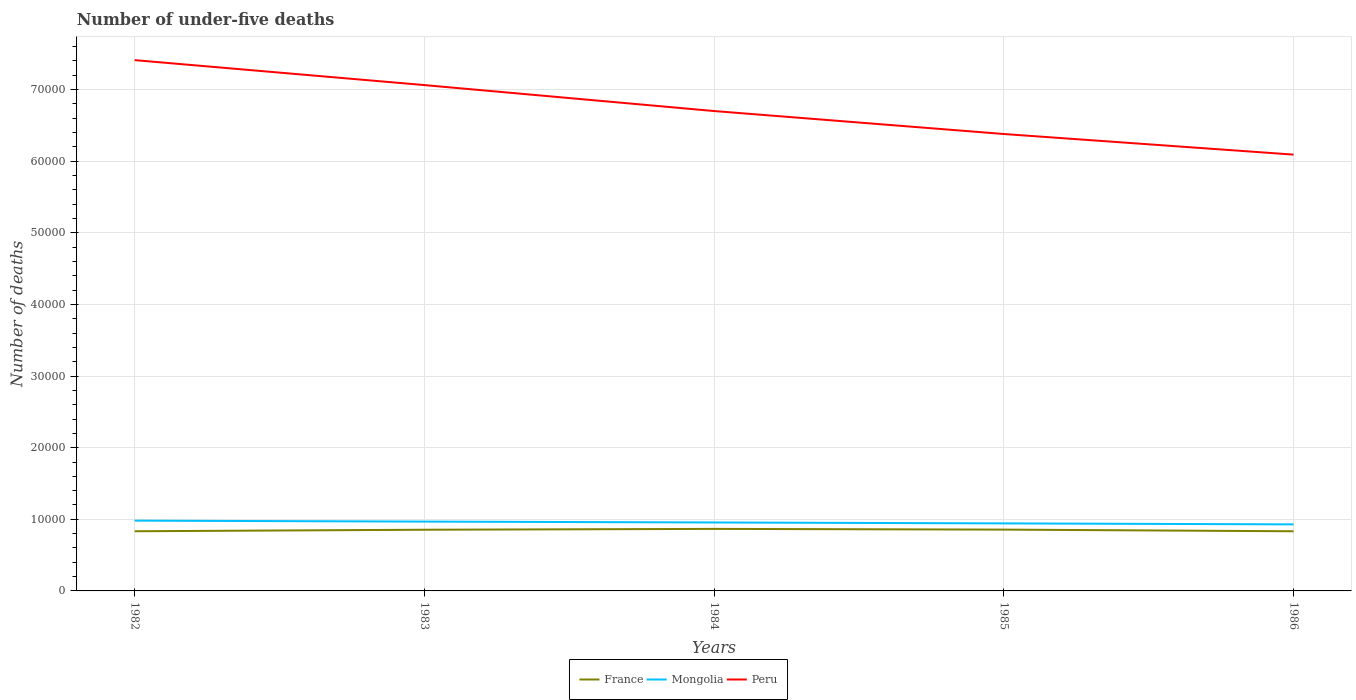How many different coloured lines are there?
Offer a very short reply. 3. Is the number of lines equal to the number of legend labels?
Ensure brevity in your answer.  Yes. Across all years, what is the maximum number of under-five deaths in France?
Your response must be concise. 8329. What is the total number of under-five deaths in Peru in the graph?
Offer a terse response. 1.03e+04. What is the difference between the highest and the second highest number of under-five deaths in Mongolia?
Ensure brevity in your answer.  523. Is the number of under-five deaths in Mongolia strictly greater than the number of under-five deaths in Peru over the years?
Keep it short and to the point. Yes. How many years are there in the graph?
Provide a succinct answer. 5. What is the difference between two consecutive major ticks on the Y-axis?
Your answer should be very brief. 10000. Does the graph contain grids?
Provide a short and direct response. Yes. How many legend labels are there?
Ensure brevity in your answer.  3. How are the legend labels stacked?
Keep it short and to the point. Horizontal. What is the title of the graph?
Provide a succinct answer. Number of under-five deaths. What is the label or title of the Y-axis?
Make the answer very short. Number of deaths. What is the Number of deaths in France in 1982?
Your response must be concise. 8331. What is the Number of deaths of Mongolia in 1982?
Ensure brevity in your answer.  9814. What is the Number of deaths in Peru in 1982?
Offer a very short reply. 7.41e+04. What is the Number of deaths in France in 1983?
Make the answer very short. 8544. What is the Number of deaths of Mongolia in 1983?
Keep it short and to the point. 9680. What is the Number of deaths in Peru in 1983?
Keep it short and to the point. 7.06e+04. What is the Number of deaths of France in 1984?
Your answer should be compact. 8662. What is the Number of deaths in Mongolia in 1984?
Ensure brevity in your answer.  9558. What is the Number of deaths in Peru in 1984?
Provide a succinct answer. 6.70e+04. What is the Number of deaths in France in 1985?
Keep it short and to the point. 8561. What is the Number of deaths in Mongolia in 1985?
Offer a terse response. 9430. What is the Number of deaths in Peru in 1985?
Ensure brevity in your answer.  6.38e+04. What is the Number of deaths of France in 1986?
Offer a very short reply. 8329. What is the Number of deaths in Mongolia in 1986?
Offer a terse response. 9291. What is the Number of deaths of Peru in 1986?
Offer a very short reply. 6.09e+04. Across all years, what is the maximum Number of deaths in France?
Make the answer very short. 8662. Across all years, what is the maximum Number of deaths in Mongolia?
Offer a terse response. 9814. Across all years, what is the maximum Number of deaths of Peru?
Ensure brevity in your answer.  7.41e+04. Across all years, what is the minimum Number of deaths in France?
Offer a very short reply. 8329. Across all years, what is the minimum Number of deaths of Mongolia?
Your response must be concise. 9291. Across all years, what is the minimum Number of deaths of Peru?
Provide a short and direct response. 6.09e+04. What is the total Number of deaths in France in the graph?
Keep it short and to the point. 4.24e+04. What is the total Number of deaths in Mongolia in the graph?
Your answer should be very brief. 4.78e+04. What is the total Number of deaths in Peru in the graph?
Provide a succinct answer. 3.36e+05. What is the difference between the Number of deaths of France in 1982 and that in 1983?
Your answer should be very brief. -213. What is the difference between the Number of deaths of Mongolia in 1982 and that in 1983?
Your response must be concise. 134. What is the difference between the Number of deaths of Peru in 1982 and that in 1983?
Make the answer very short. 3484. What is the difference between the Number of deaths in France in 1982 and that in 1984?
Your answer should be compact. -331. What is the difference between the Number of deaths in Mongolia in 1982 and that in 1984?
Your answer should be very brief. 256. What is the difference between the Number of deaths of Peru in 1982 and that in 1984?
Your response must be concise. 7108. What is the difference between the Number of deaths of France in 1982 and that in 1985?
Ensure brevity in your answer.  -230. What is the difference between the Number of deaths in Mongolia in 1982 and that in 1985?
Your answer should be compact. 384. What is the difference between the Number of deaths of Peru in 1982 and that in 1985?
Offer a very short reply. 1.03e+04. What is the difference between the Number of deaths in France in 1982 and that in 1986?
Your answer should be very brief. 2. What is the difference between the Number of deaths in Mongolia in 1982 and that in 1986?
Your response must be concise. 523. What is the difference between the Number of deaths of Peru in 1982 and that in 1986?
Your response must be concise. 1.32e+04. What is the difference between the Number of deaths of France in 1983 and that in 1984?
Give a very brief answer. -118. What is the difference between the Number of deaths in Mongolia in 1983 and that in 1984?
Your answer should be compact. 122. What is the difference between the Number of deaths in Peru in 1983 and that in 1984?
Offer a very short reply. 3624. What is the difference between the Number of deaths in Mongolia in 1983 and that in 1985?
Make the answer very short. 250. What is the difference between the Number of deaths of Peru in 1983 and that in 1985?
Keep it short and to the point. 6831. What is the difference between the Number of deaths of France in 1983 and that in 1986?
Ensure brevity in your answer.  215. What is the difference between the Number of deaths of Mongolia in 1983 and that in 1986?
Your answer should be compact. 389. What is the difference between the Number of deaths in Peru in 1983 and that in 1986?
Give a very brief answer. 9709. What is the difference between the Number of deaths in France in 1984 and that in 1985?
Offer a very short reply. 101. What is the difference between the Number of deaths in Mongolia in 1984 and that in 1985?
Provide a succinct answer. 128. What is the difference between the Number of deaths in Peru in 1984 and that in 1985?
Your answer should be compact. 3207. What is the difference between the Number of deaths of France in 1984 and that in 1986?
Ensure brevity in your answer.  333. What is the difference between the Number of deaths of Mongolia in 1984 and that in 1986?
Keep it short and to the point. 267. What is the difference between the Number of deaths of Peru in 1984 and that in 1986?
Keep it short and to the point. 6085. What is the difference between the Number of deaths in France in 1985 and that in 1986?
Keep it short and to the point. 232. What is the difference between the Number of deaths in Mongolia in 1985 and that in 1986?
Your response must be concise. 139. What is the difference between the Number of deaths in Peru in 1985 and that in 1986?
Provide a short and direct response. 2878. What is the difference between the Number of deaths in France in 1982 and the Number of deaths in Mongolia in 1983?
Provide a short and direct response. -1349. What is the difference between the Number of deaths of France in 1982 and the Number of deaths of Peru in 1983?
Ensure brevity in your answer.  -6.23e+04. What is the difference between the Number of deaths of Mongolia in 1982 and the Number of deaths of Peru in 1983?
Your answer should be compact. -6.08e+04. What is the difference between the Number of deaths in France in 1982 and the Number of deaths in Mongolia in 1984?
Keep it short and to the point. -1227. What is the difference between the Number of deaths in France in 1982 and the Number of deaths in Peru in 1984?
Ensure brevity in your answer.  -5.87e+04. What is the difference between the Number of deaths of Mongolia in 1982 and the Number of deaths of Peru in 1984?
Your answer should be very brief. -5.72e+04. What is the difference between the Number of deaths of France in 1982 and the Number of deaths of Mongolia in 1985?
Ensure brevity in your answer.  -1099. What is the difference between the Number of deaths in France in 1982 and the Number of deaths in Peru in 1985?
Give a very brief answer. -5.55e+04. What is the difference between the Number of deaths of Mongolia in 1982 and the Number of deaths of Peru in 1985?
Offer a very short reply. -5.40e+04. What is the difference between the Number of deaths of France in 1982 and the Number of deaths of Mongolia in 1986?
Your answer should be very brief. -960. What is the difference between the Number of deaths of France in 1982 and the Number of deaths of Peru in 1986?
Provide a succinct answer. -5.26e+04. What is the difference between the Number of deaths of Mongolia in 1982 and the Number of deaths of Peru in 1986?
Make the answer very short. -5.11e+04. What is the difference between the Number of deaths of France in 1983 and the Number of deaths of Mongolia in 1984?
Your response must be concise. -1014. What is the difference between the Number of deaths of France in 1983 and the Number of deaths of Peru in 1984?
Provide a succinct answer. -5.85e+04. What is the difference between the Number of deaths of Mongolia in 1983 and the Number of deaths of Peru in 1984?
Ensure brevity in your answer.  -5.73e+04. What is the difference between the Number of deaths in France in 1983 and the Number of deaths in Mongolia in 1985?
Offer a terse response. -886. What is the difference between the Number of deaths of France in 1983 and the Number of deaths of Peru in 1985?
Offer a very short reply. -5.53e+04. What is the difference between the Number of deaths in Mongolia in 1983 and the Number of deaths in Peru in 1985?
Provide a short and direct response. -5.41e+04. What is the difference between the Number of deaths of France in 1983 and the Number of deaths of Mongolia in 1986?
Provide a succinct answer. -747. What is the difference between the Number of deaths in France in 1983 and the Number of deaths in Peru in 1986?
Offer a very short reply. -5.24e+04. What is the difference between the Number of deaths in Mongolia in 1983 and the Number of deaths in Peru in 1986?
Offer a terse response. -5.12e+04. What is the difference between the Number of deaths in France in 1984 and the Number of deaths in Mongolia in 1985?
Offer a very short reply. -768. What is the difference between the Number of deaths of France in 1984 and the Number of deaths of Peru in 1985?
Your answer should be compact. -5.51e+04. What is the difference between the Number of deaths in Mongolia in 1984 and the Number of deaths in Peru in 1985?
Keep it short and to the point. -5.42e+04. What is the difference between the Number of deaths in France in 1984 and the Number of deaths in Mongolia in 1986?
Your answer should be very brief. -629. What is the difference between the Number of deaths of France in 1984 and the Number of deaths of Peru in 1986?
Provide a succinct answer. -5.23e+04. What is the difference between the Number of deaths of Mongolia in 1984 and the Number of deaths of Peru in 1986?
Offer a very short reply. -5.14e+04. What is the difference between the Number of deaths in France in 1985 and the Number of deaths in Mongolia in 1986?
Offer a very short reply. -730. What is the difference between the Number of deaths in France in 1985 and the Number of deaths in Peru in 1986?
Provide a short and direct response. -5.24e+04. What is the difference between the Number of deaths of Mongolia in 1985 and the Number of deaths of Peru in 1986?
Offer a terse response. -5.15e+04. What is the average Number of deaths in France per year?
Make the answer very short. 8485.4. What is the average Number of deaths in Mongolia per year?
Offer a very short reply. 9554.6. What is the average Number of deaths of Peru per year?
Ensure brevity in your answer.  6.73e+04. In the year 1982, what is the difference between the Number of deaths in France and Number of deaths in Mongolia?
Your response must be concise. -1483. In the year 1982, what is the difference between the Number of deaths in France and Number of deaths in Peru?
Offer a very short reply. -6.58e+04. In the year 1982, what is the difference between the Number of deaths of Mongolia and Number of deaths of Peru?
Provide a short and direct response. -6.43e+04. In the year 1983, what is the difference between the Number of deaths in France and Number of deaths in Mongolia?
Your response must be concise. -1136. In the year 1983, what is the difference between the Number of deaths of France and Number of deaths of Peru?
Your response must be concise. -6.21e+04. In the year 1983, what is the difference between the Number of deaths of Mongolia and Number of deaths of Peru?
Your answer should be compact. -6.09e+04. In the year 1984, what is the difference between the Number of deaths in France and Number of deaths in Mongolia?
Your answer should be compact. -896. In the year 1984, what is the difference between the Number of deaths of France and Number of deaths of Peru?
Offer a very short reply. -5.83e+04. In the year 1984, what is the difference between the Number of deaths of Mongolia and Number of deaths of Peru?
Offer a very short reply. -5.74e+04. In the year 1985, what is the difference between the Number of deaths of France and Number of deaths of Mongolia?
Your answer should be compact. -869. In the year 1985, what is the difference between the Number of deaths of France and Number of deaths of Peru?
Provide a succinct answer. -5.52e+04. In the year 1985, what is the difference between the Number of deaths in Mongolia and Number of deaths in Peru?
Provide a short and direct response. -5.44e+04. In the year 1986, what is the difference between the Number of deaths of France and Number of deaths of Mongolia?
Your answer should be very brief. -962. In the year 1986, what is the difference between the Number of deaths of France and Number of deaths of Peru?
Give a very brief answer. -5.26e+04. In the year 1986, what is the difference between the Number of deaths of Mongolia and Number of deaths of Peru?
Offer a very short reply. -5.16e+04. What is the ratio of the Number of deaths of France in 1982 to that in 1983?
Your answer should be very brief. 0.98. What is the ratio of the Number of deaths in Mongolia in 1982 to that in 1983?
Your response must be concise. 1.01. What is the ratio of the Number of deaths of Peru in 1982 to that in 1983?
Your answer should be compact. 1.05. What is the ratio of the Number of deaths of France in 1982 to that in 1984?
Give a very brief answer. 0.96. What is the ratio of the Number of deaths in Mongolia in 1982 to that in 1984?
Your answer should be very brief. 1.03. What is the ratio of the Number of deaths in Peru in 1982 to that in 1984?
Provide a short and direct response. 1.11. What is the ratio of the Number of deaths in France in 1982 to that in 1985?
Give a very brief answer. 0.97. What is the ratio of the Number of deaths in Mongolia in 1982 to that in 1985?
Keep it short and to the point. 1.04. What is the ratio of the Number of deaths of Peru in 1982 to that in 1985?
Ensure brevity in your answer.  1.16. What is the ratio of the Number of deaths of Mongolia in 1982 to that in 1986?
Your answer should be compact. 1.06. What is the ratio of the Number of deaths in Peru in 1982 to that in 1986?
Offer a terse response. 1.22. What is the ratio of the Number of deaths in France in 1983 to that in 1984?
Ensure brevity in your answer.  0.99. What is the ratio of the Number of deaths of Mongolia in 1983 to that in 1984?
Offer a very short reply. 1.01. What is the ratio of the Number of deaths of Peru in 1983 to that in 1984?
Make the answer very short. 1.05. What is the ratio of the Number of deaths in France in 1983 to that in 1985?
Provide a short and direct response. 1. What is the ratio of the Number of deaths of Mongolia in 1983 to that in 1985?
Your answer should be very brief. 1.03. What is the ratio of the Number of deaths of Peru in 1983 to that in 1985?
Your answer should be very brief. 1.11. What is the ratio of the Number of deaths of France in 1983 to that in 1986?
Give a very brief answer. 1.03. What is the ratio of the Number of deaths in Mongolia in 1983 to that in 1986?
Offer a very short reply. 1.04. What is the ratio of the Number of deaths in Peru in 1983 to that in 1986?
Your answer should be compact. 1.16. What is the ratio of the Number of deaths in France in 1984 to that in 1985?
Your answer should be compact. 1.01. What is the ratio of the Number of deaths of Mongolia in 1984 to that in 1985?
Your response must be concise. 1.01. What is the ratio of the Number of deaths in Peru in 1984 to that in 1985?
Keep it short and to the point. 1.05. What is the ratio of the Number of deaths in France in 1984 to that in 1986?
Your response must be concise. 1.04. What is the ratio of the Number of deaths in Mongolia in 1984 to that in 1986?
Provide a short and direct response. 1.03. What is the ratio of the Number of deaths in Peru in 1984 to that in 1986?
Make the answer very short. 1.1. What is the ratio of the Number of deaths in France in 1985 to that in 1986?
Your response must be concise. 1.03. What is the ratio of the Number of deaths in Peru in 1985 to that in 1986?
Your answer should be very brief. 1.05. What is the difference between the highest and the second highest Number of deaths in France?
Provide a short and direct response. 101. What is the difference between the highest and the second highest Number of deaths of Mongolia?
Make the answer very short. 134. What is the difference between the highest and the second highest Number of deaths of Peru?
Your answer should be compact. 3484. What is the difference between the highest and the lowest Number of deaths of France?
Offer a terse response. 333. What is the difference between the highest and the lowest Number of deaths in Mongolia?
Your answer should be compact. 523. What is the difference between the highest and the lowest Number of deaths of Peru?
Offer a very short reply. 1.32e+04. 